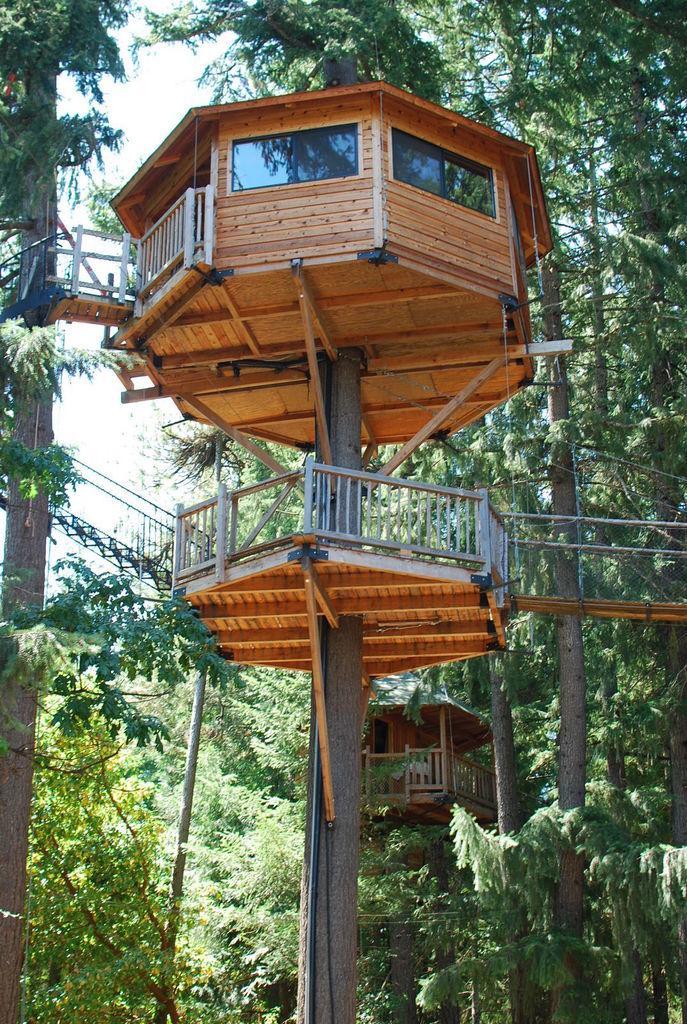How would you summarize this image in a sentence or two? In this image I can see number of trees and I can also see two tree houses on the trees. On the both sides of the image I can see bridges and in the background I can see the sky. 